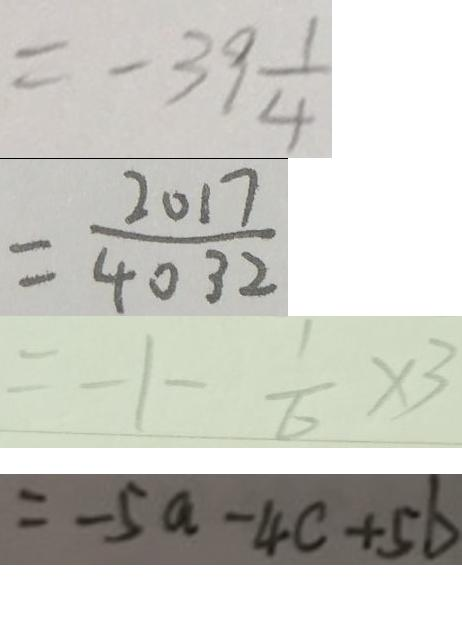Convert formula to latex. <formula><loc_0><loc_0><loc_500><loc_500>= - 3 9 \frac { 1 } { 4 } 
 = \frac { 2 0 1 7 } { 4 0 3 2 } 
 = - 1 - \frac { 1 } { 6 } \times 3 
 = - 5 a - 4 c + 5 b</formula> 